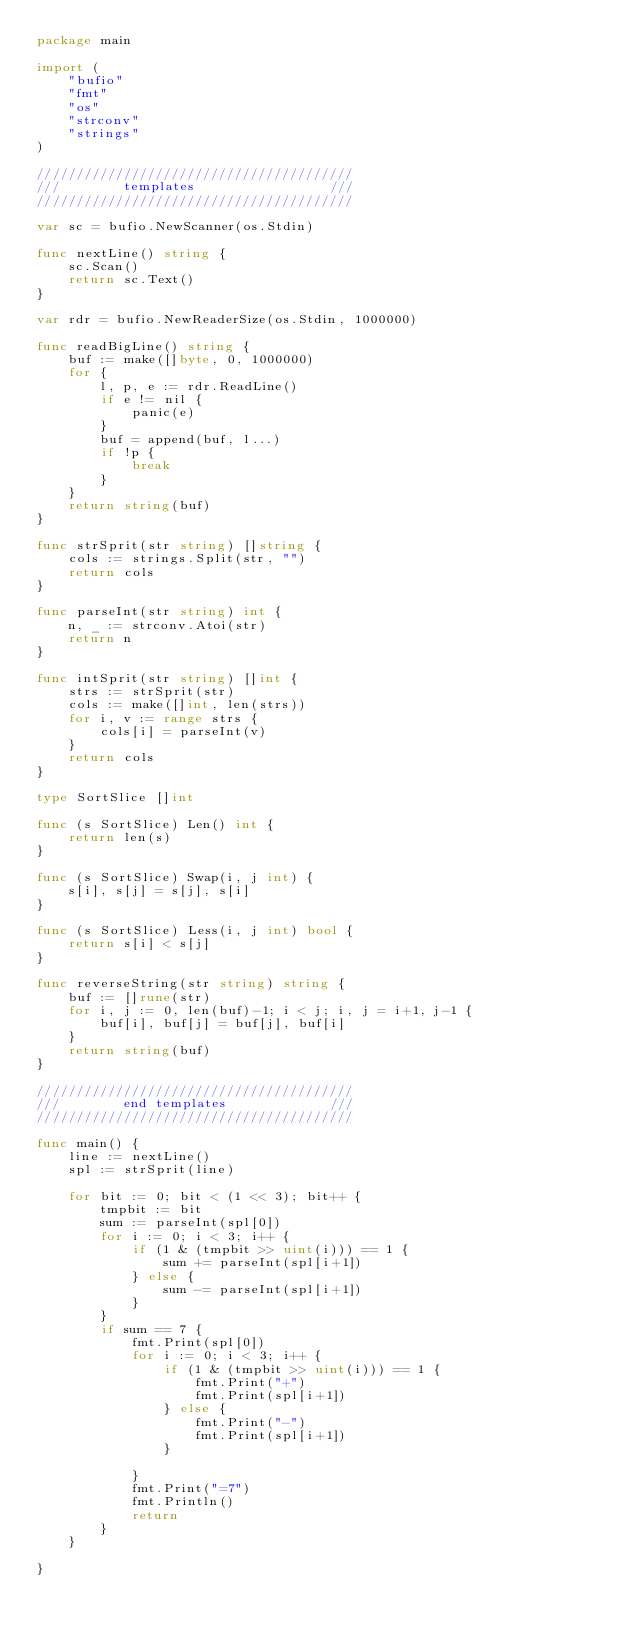<code> <loc_0><loc_0><loc_500><loc_500><_Go_>package main

import (
	"bufio"
	"fmt"
	"os"
	"strconv"
	"strings"
)

////////////////////////////////////////
///        templates                 ///
////////////////////////////////////////

var sc = bufio.NewScanner(os.Stdin)

func nextLine() string {
	sc.Scan()
	return sc.Text()
}

var rdr = bufio.NewReaderSize(os.Stdin, 1000000)

func readBigLine() string {
	buf := make([]byte, 0, 1000000)
	for {
		l, p, e := rdr.ReadLine()
		if e != nil {
			panic(e)
		}
		buf = append(buf, l...)
		if !p {
			break
		}
	}
	return string(buf)
}

func strSprit(str string) []string {
	cols := strings.Split(str, "")
	return cols
}

func parseInt(str string) int {
	n, _ := strconv.Atoi(str)
	return n
}

func intSprit(str string) []int {
	strs := strSprit(str)
	cols := make([]int, len(strs))
	for i, v := range strs {
		cols[i] = parseInt(v)
	}
	return cols
}

type SortSlice []int

func (s SortSlice) Len() int {
	return len(s)
}

func (s SortSlice) Swap(i, j int) {
	s[i], s[j] = s[j], s[i]
}

func (s SortSlice) Less(i, j int) bool {
	return s[i] < s[j]
}

func reverseString(str string) string {
	buf := []rune(str)
	for i, j := 0, len(buf)-1; i < j; i, j = i+1, j-1 {
		buf[i], buf[j] = buf[j], buf[i]
	}
	return string(buf)
}

////////////////////////////////////////
///        end templates             ///
////////////////////////////////////////

func main() {
	line := nextLine()
	spl := strSprit(line)

	for bit := 0; bit < (1 << 3); bit++ {
		tmpbit := bit
		sum := parseInt(spl[0])
		for i := 0; i < 3; i++ {
			if (1 & (tmpbit >> uint(i))) == 1 {
				sum += parseInt(spl[i+1])
			} else {
				sum -= parseInt(spl[i+1])
			}
		}
		if sum == 7 {
			fmt.Print(spl[0])
			for i := 0; i < 3; i++ {
				if (1 & (tmpbit >> uint(i))) == 1 {
					fmt.Print("+")
					fmt.Print(spl[i+1])
				} else {
					fmt.Print("-")
					fmt.Print(spl[i+1])
				}

			}
			fmt.Print("=7")
			fmt.Println()
			return
		}
	}

}
</code> 